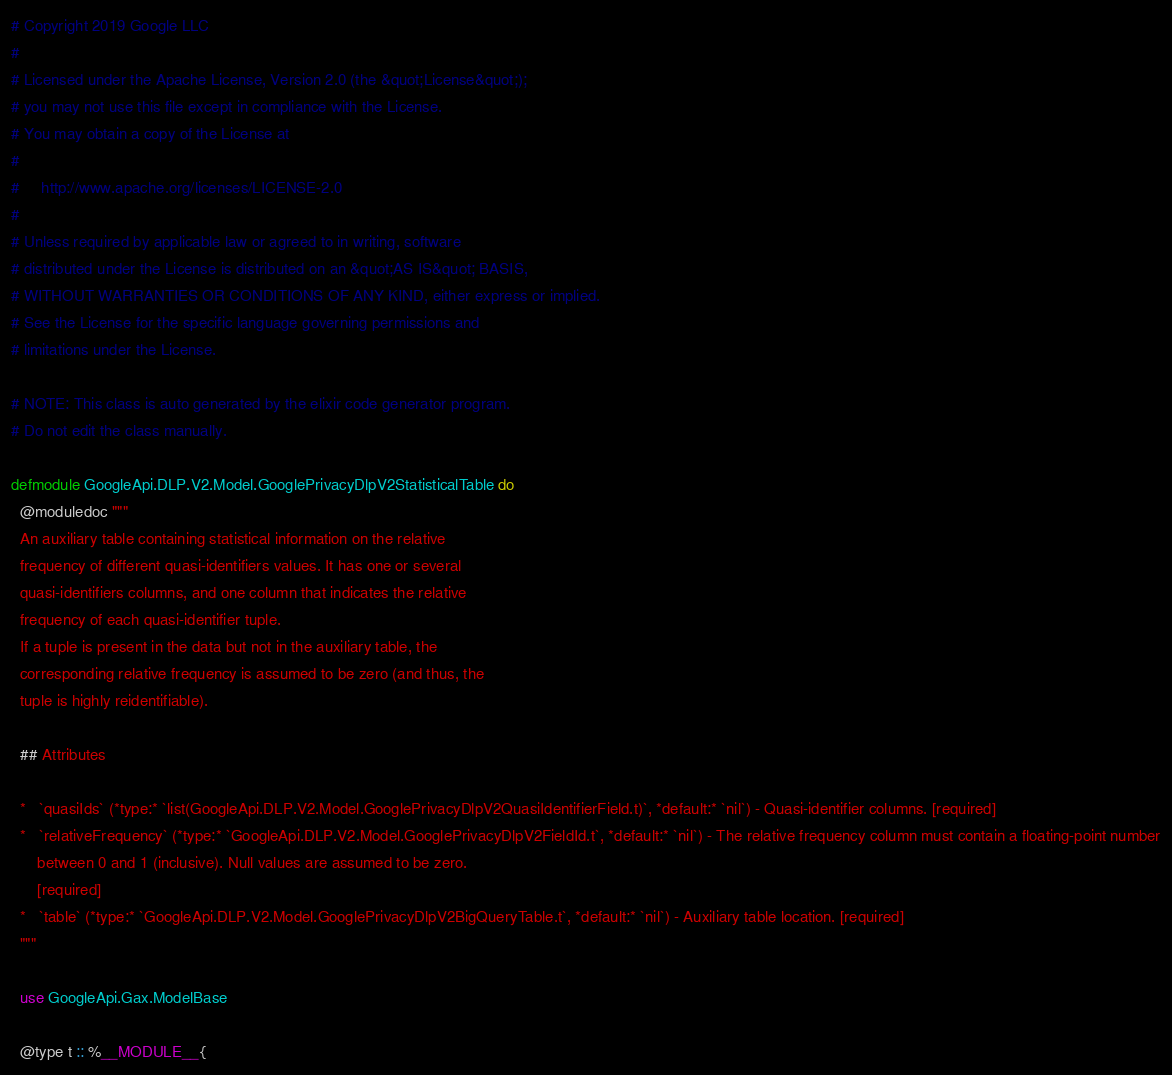Convert code to text. <code><loc_0><loc_0><loc_500><loc_500><_Elixir_># Copyright 2019 Google LLC
#
# Licensed under the Apache License, Version 2.0 (the &quot;License&quot;);
# you may not use this file except in compliance with the License.
# You may obtain a copy of the License at
#
#     http://www.apache.org/licenses/LICENSE-2.0
#
# Unless required by applicable law or agreed to in writing, software
# distributed under the License is distributed on an &quot;AS IS&quot; BASIS,
# WITHOUT WARRANTIES OR CONDITIONS OF ANY KIND, either express or implied.
# See the License for the specific language governing permissions and
# limitations under the License.

# NOTE: This class is auto generated by the elixir code generator program.
# Do not edit the class manually.

defmodule GoogleApi.DLP.V2.Model.GooglePrivacyDlpV2StatisticalTable do
  @moduledoc """
  An auxiliary table containing statistical information on the relative
  frequency of different quasi-identifiers values. It has one or several
  quasi-identifiers columns, and one column that indicates the relative
  frequency of each quasi-identifier tuple.
  If a tuple is present in the data but not in the auxiliary table, the
  corresponding relative frequency is assumed to be zero (and thus, the
  tuple is highly reidentifiable).

  ## Attributes

  *   `quasiIds` (*type:* `list(GoogleApi.DLP.V2.Model.GooglePrivacyDlpV2QuasiIdentifierField.t)`, *default:* `nil`) - Quasi-identifier columns. [required]
  *   `relativeFrequency` (*type:* `GoogleApi.DLP.V2.Model.GooglePrivacyDlpV2FieldId.t`, *default:* `nil`) - The relative frequency column must contain a floating-point number
      between 0 and 1 (inclusive). Null values are assumed to be zero.
      [required]
  *   `table` (*type:* `GoogleApi.DLP.V2.Model.GooglePrivacyDlpV2BigQueryTable.t`, *default:* `nil`) - Auxiliary table location. [required]
  """

  use GoogleApi.Gax.ModelBase

  @type t :: %__MODULE__{</code> 